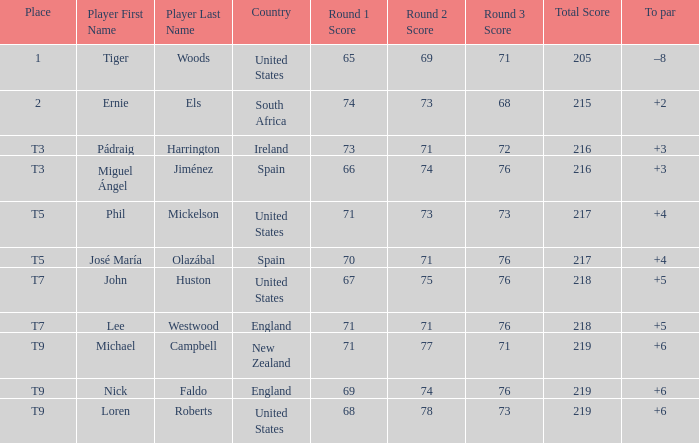What is Player, when Country is "England", and when Place is "T7"? Lee Westwood. 